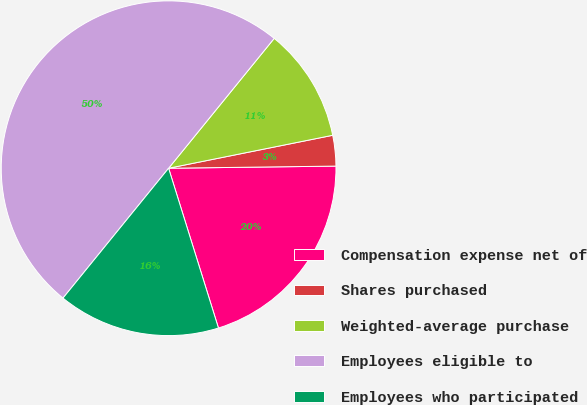Convert chart to OTSL. <chart><loc_0><loc_0><loc_500><loc_500><pie_chart><fcel>Compensation expense net of<fcel>Shares purchased<fcel>Weighted-average purchase<fcel>Employees eligible to<fcel>Employees who participated<nl><fcel>20.39%<fcel>2.95%<fcel>10.98%<fcel>50.0%<fcel>15.68%<nl></chart> 